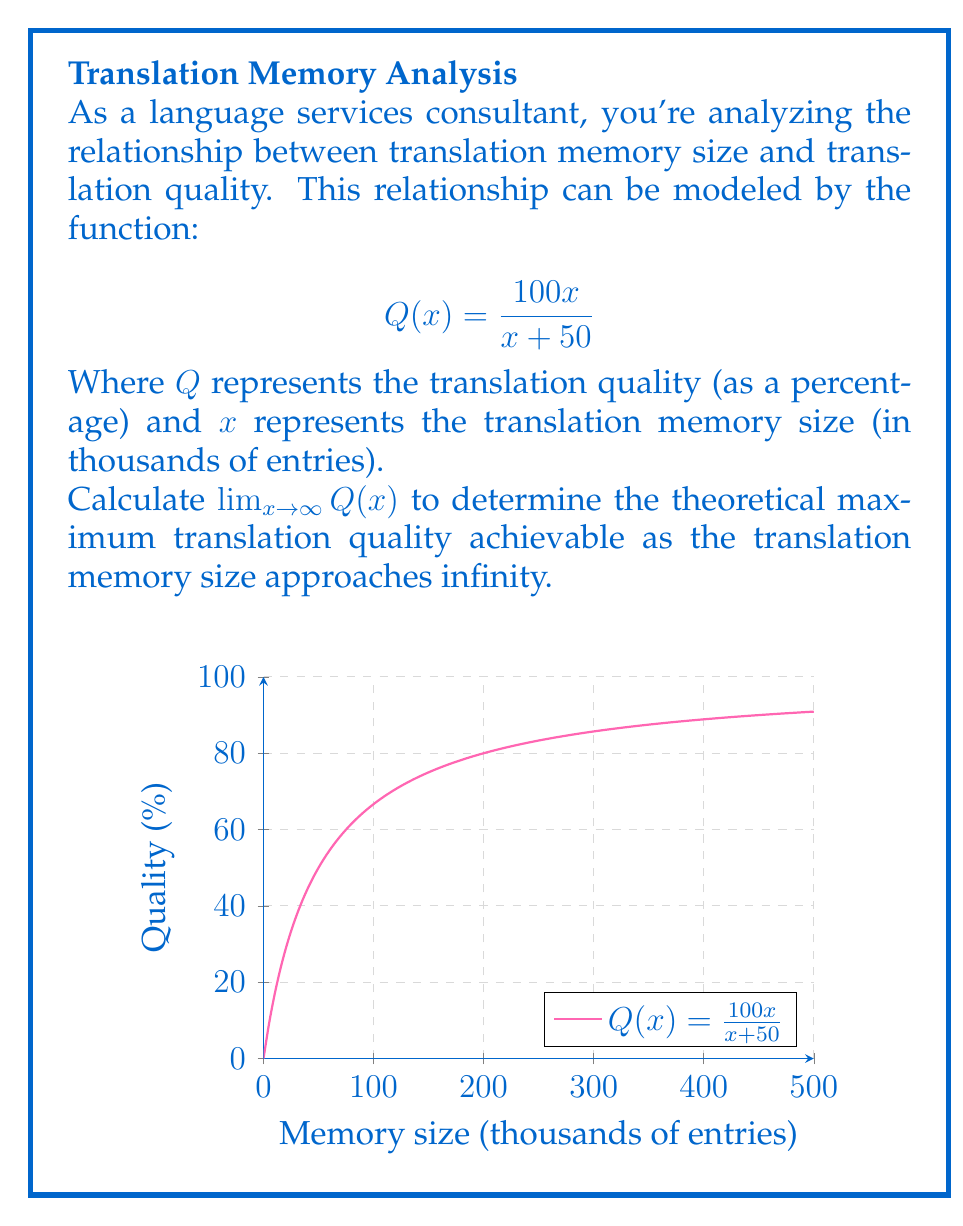Provide a solution to this math problem. To solve this limit problem, we'll follow these steps:

1) First, let's recall that for a rational function $\frac{P(x)}{Q(x)}$, where $P(x)$ and $Q(x)$ are polynomials, the limit as $x$ approaches infinity is determined by comparing the degrees of $P(x)$ and $Q(x)$.

2) In our case, we have:

   $$\lim_{x \to \infty} Q(x) = \lim_{x \to \infty} \frac{100x}{x + 50}$$

3) Both the numerator and denominator have degree 1, so we can find the limit by dividing the leading coefficients:

   $$\lim_{x \to \infty} \frac{100x}{x + 50} = \frac{100}{1} = 100$$

4) We can verify this result using the following method:
   Divide both numerator and denominator by the highest power of $x$ in the denominator (in this case, $x^1$):

   $$\lim_{x \to \infty} \frac{100x}{x + 50} = \lim_{x \to \infty} \frac{100x/x}{(x + 50)/x} = \lim_{x \to \infty} \frac{100}{1 + 50/x}$$

5) As $x$ approaches infinity, $50/x$ approaches 0:

   $$\lim_{x \to \infty} \frac{100}{1 + 50/x} = \frac{100}{1 + 0} = 100$$

This result indicates that as the translation memory size grows infinitely large, the translation quality approaches 100%.
Answer: 100 